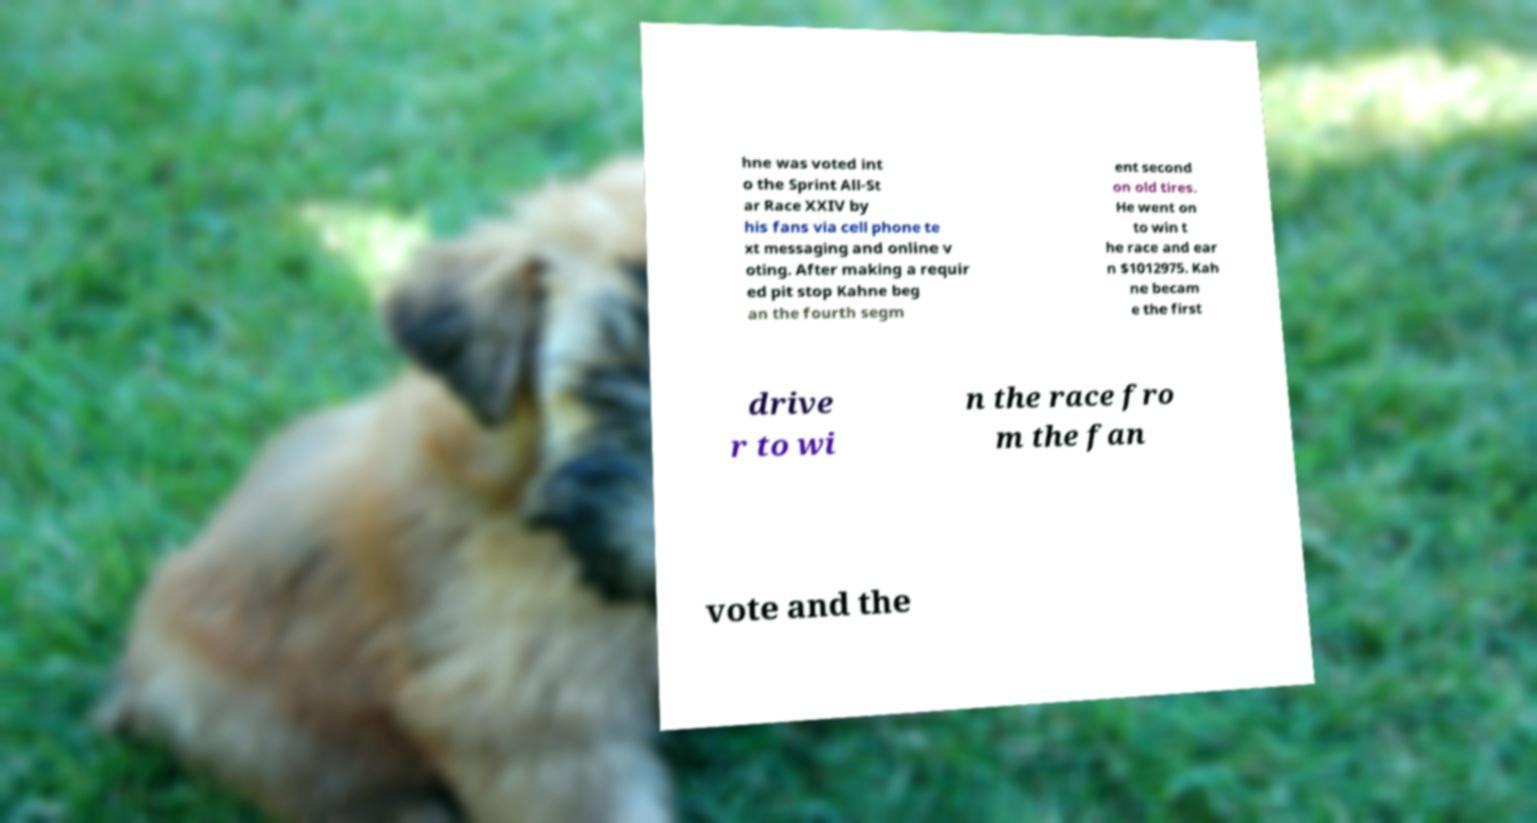Could you extract and type out the text from this image? hne was voted int o the Sprint All-St ar Race XXIV by his fans via cell phone te xt messaging and online v oting. After making a requir ed pit stop Kahne beg an the fourth segm ent second on old tires. He went on to win t he race and ear n $1012975. Kah ne becam e the first drive r to wi n the race fro m the fan vote and the 